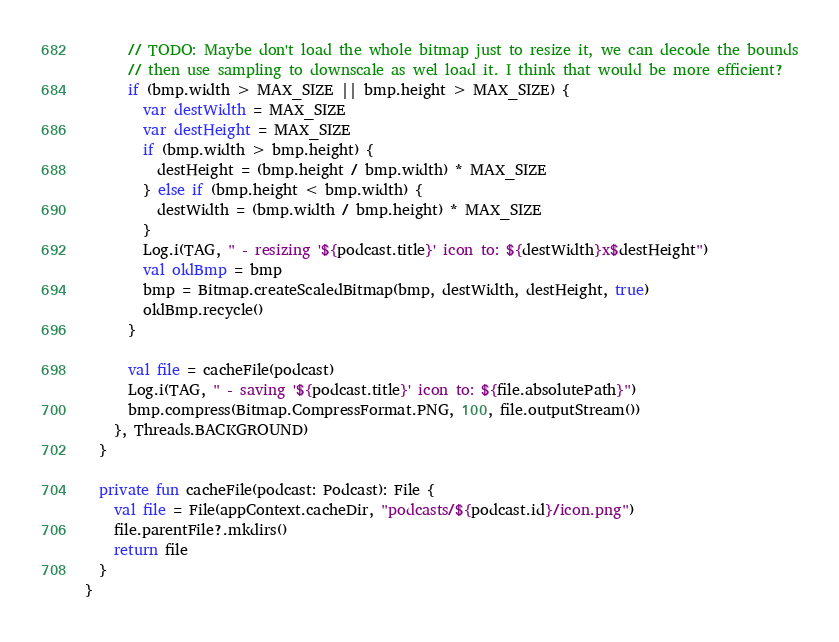<code> <loc_0><loc_0><loc_500><loc_500><_Kotlin_>      // TODO: Maybe don't load the whole bitmap just to resize it, we can decode the bounds
      // then use sampling to downscale as wel load it. I think that would be more efficient?
      if (bmp.width > MAX_SIZE || bmp.height > MAX_SIZE) {
        var destWidth = MAX_SIZE
        var destHeight = MAX_SIZE
        if (bmp.width > bmp.height) {
          destHeight = (bmp.height / bmp.width) * MAX_SIZE
        } else if (bmp.height < bmp.width) {
          destWidth = (bmp.width / bmp.height) * MAX_SIZE
        }
        Log.i(TAG, " - resizing '${podcast.title}' icon to: ${destWidth}x$destHeight")
        val oldBmp = bmp
        bmp = Bitmap.createScaledBitmap(bmp, destWidth, destHeight, true)
        oldBmp.recycle()
      }

      val file = cacheFile(podcast)
      Log.i(TAG, " - saving '${podcast.title}' icon to: ${file.absolutePath}")
      bmp.compress(Bitmap.CompressFormat.PNG, 100, file.outputStream())
    }, Threads.BACKGROUND)
  }

  private fun cacheFile(podcast: Podcast): File {
    val file = File(appContext.cacheDir, "podcasts/${podcast.id}/icon.png")
    file.parentFile?.mkdirs()
    return file
  }
}</code> 